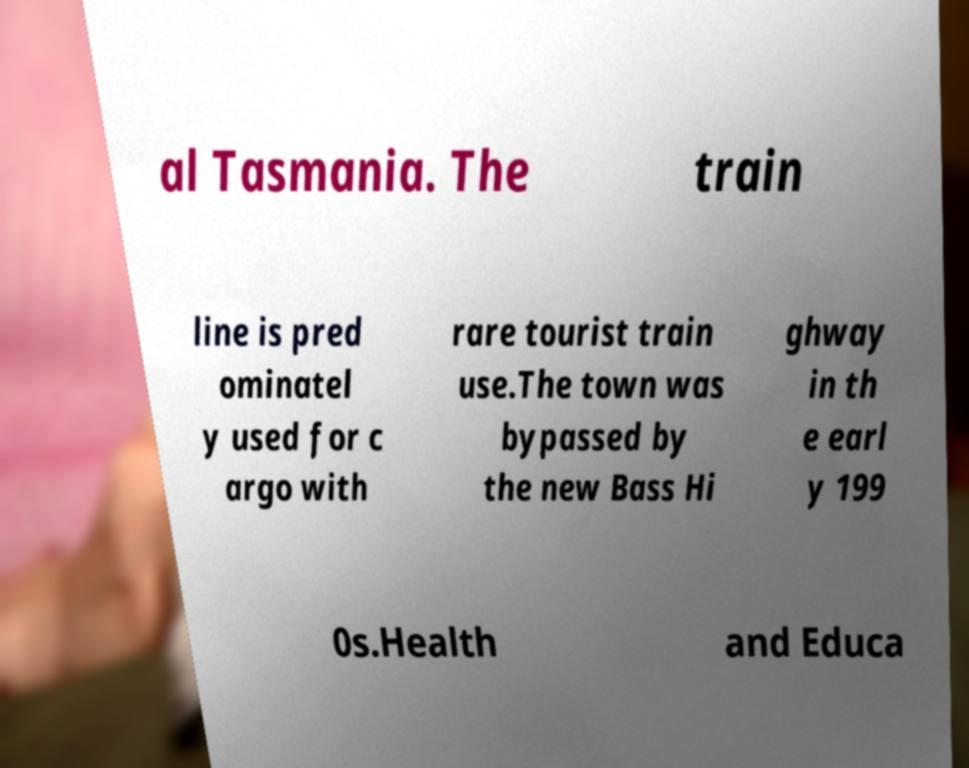Can you accurately transcribe the text from the provided image for me? al Tasmania. The train line is pred ominatel y used for c argo with rare tourist train use.The town was bypassed by the new Bass Hi ghway in th e earl y 199 0s.Health and Educa 